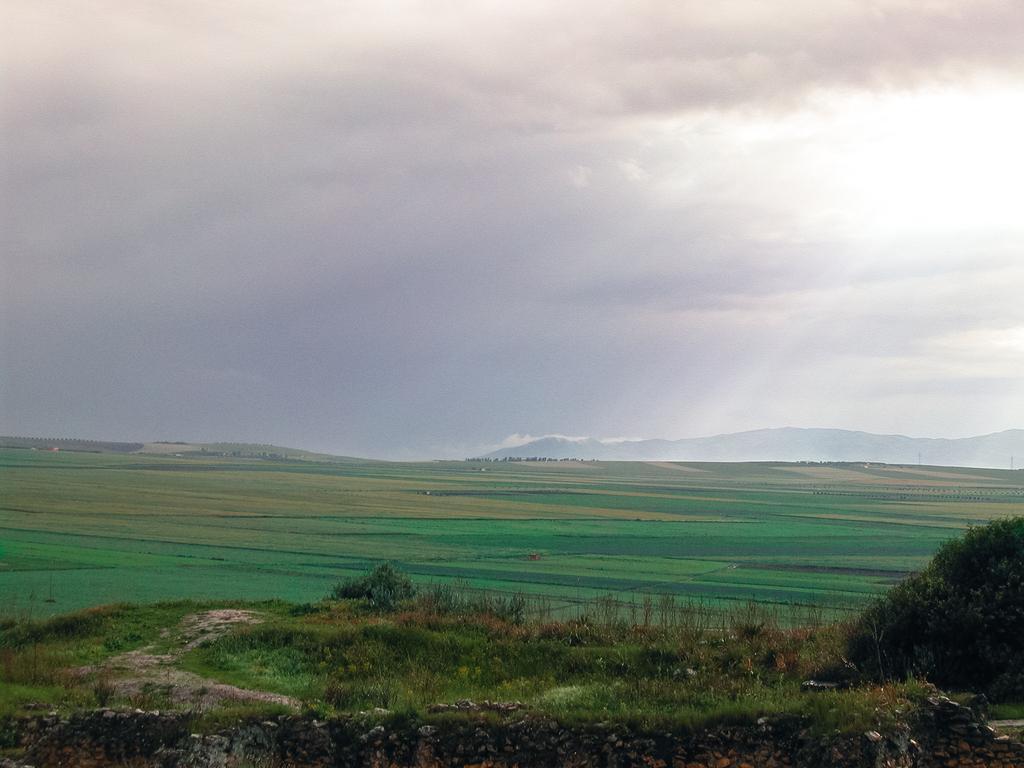Can you describe this image briefly? As we can see in the image in the front there is grass and plant. In the background there are hills. At the top there is sky and clouds. 